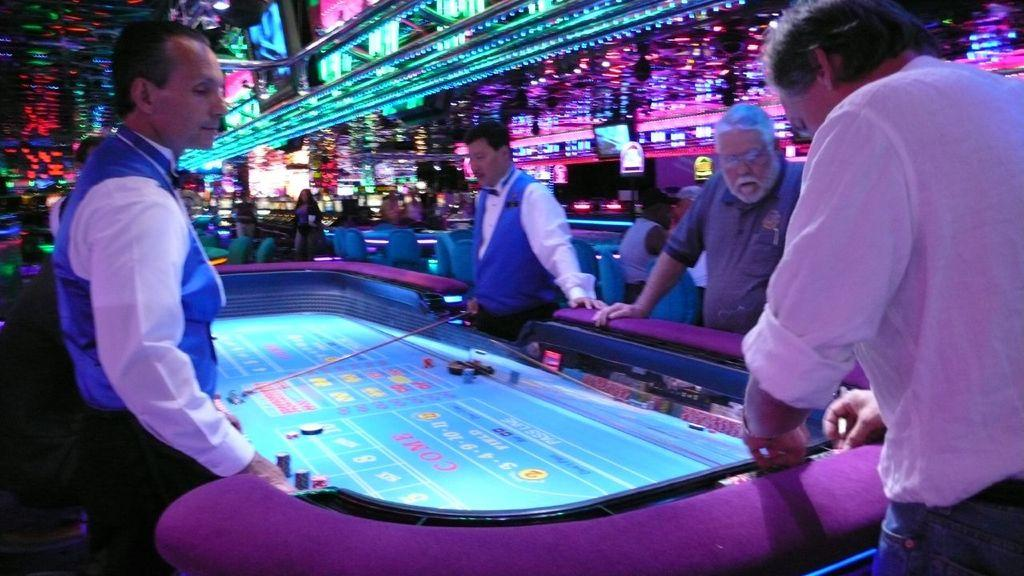What can be seen in the image? There is a group of people in the image. Can you describe the person in front? The person in front is wearing a white shirt and blue pants. What is happening in the background of the image? There are people standing in the background of the image, and colorful lights are visible. What type of prose is being recited by the person in the blue pants? There is no indication in the image that anyone is reciting prose, and the person in the blue pants is not mentioned to be speaking. 